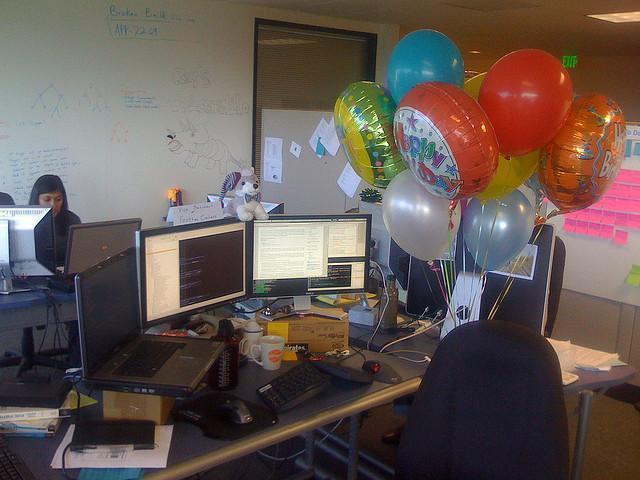What sort of wax item might be on a dessert enjoyed by the person sitting by the balloons today?
Select the accurate answer and provide justification: `Answer: choice
Rationale: srationale.`
Options: Waxed nails, joke teeth, moon, birthday candle. Answer: birthday candle.
Rationale: A birthday cake usually has candles on it. 